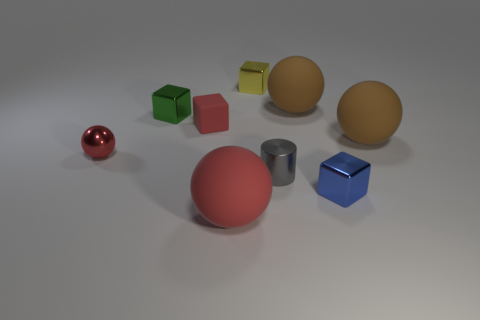Subtract all small red cubes. How many cubes are left? 3 Subtract all brown spheres. How many spheres are left? 2 Subtract all spheres. How many objects are left? 5 Subtract 1 cylinders. How many cylinders are left? 0 Add 4 big brown balls. How many big brown balls exist? 6 Subtract 0 purple cylinders. How many objects are left? 9 Subtract all red blocks. Subtract all brown cylinders. How many blocks are left? 3 Subtract all purple cylinders. How many red cubes are left? 1 Subtract all big yellow cylinders. Subtract all big red rubber balls. How many objects are left? 8 Add 6 large brown objects. How many large brown objects are left? 8 